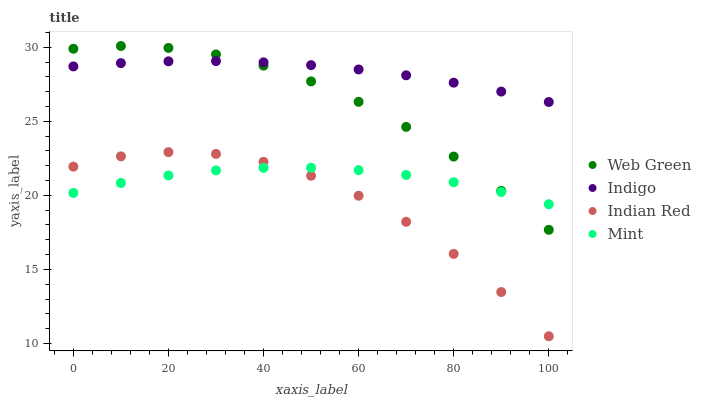Does Indian Red have the minimum area under the curve?
Answer yes or no. Yes. Does Indigo have the maximum area under the curve?
Answer yes or no. Yes. Does Indigo have the minimum area under the curve?
Answer yes or no. No. Does Indian Red have the maximum area under the curve?
Answer yes or no. No. Is Indigo the smoothest?
Answer yes or no. Yes. Is Indian Red the roughest?
Answer yes or no. Yes. Is Indian Red the smoothest?
Answer yes or no. No. Is Indigo the roughest?
Answer yes or no. No. Does Indian Red have the lowest value?
Answer yes or no. Yes. Does Indigo have the lowest value?
Answer yes or no. No. Does Web Green have the highest value?
Answer yes or no. Yes. Does Indigo have the highest value?
Answer yes or no. No. Is Mint less than Indigo?
Answer yes or no. Yes. Is Web Green greater than Indian Red?
Answer yes or no. Yes. Does Mint intersect Indian Red?
Answer yes or no. Yes. Is Mint less than Indian Red?
Answer yes or no. No. Is Mint greater than Indian Red?
Answer yes or no. No. Does Mint intersect Indigo?
Answer yes or no. No. 